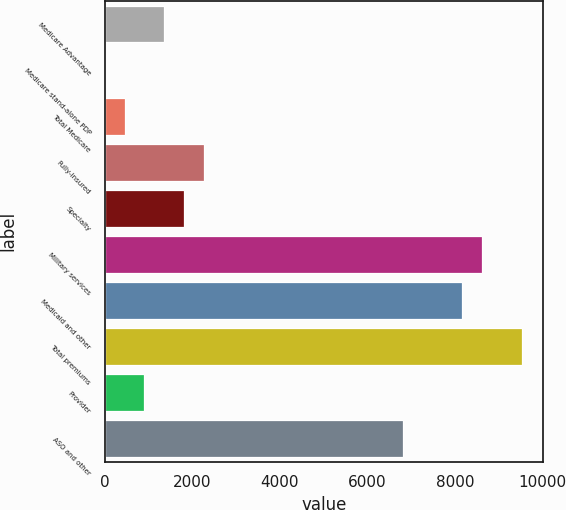<chart> <loc_0><loc_0><loc_500><loc_500><bar_chart><fcel>Medicare Advantage<fcel>Medicare stand-alone PDP<fcel>Total Medicare<fcel>Fully-insured<fcel>Specialty<fcel>Military services<fcel>Medicaid and other<fcel>Total premiums<fcel>Provider<fcel>ASO and other<nl><fcel>1361.49<fcel>0.57<fcel>454.21<fcel>2268.77<fcel>1815.13<fcel>8619.73<fcel>8166.09<fcel>9527.01<fcel>907.85<fcel>6805.17<nl></chart> 